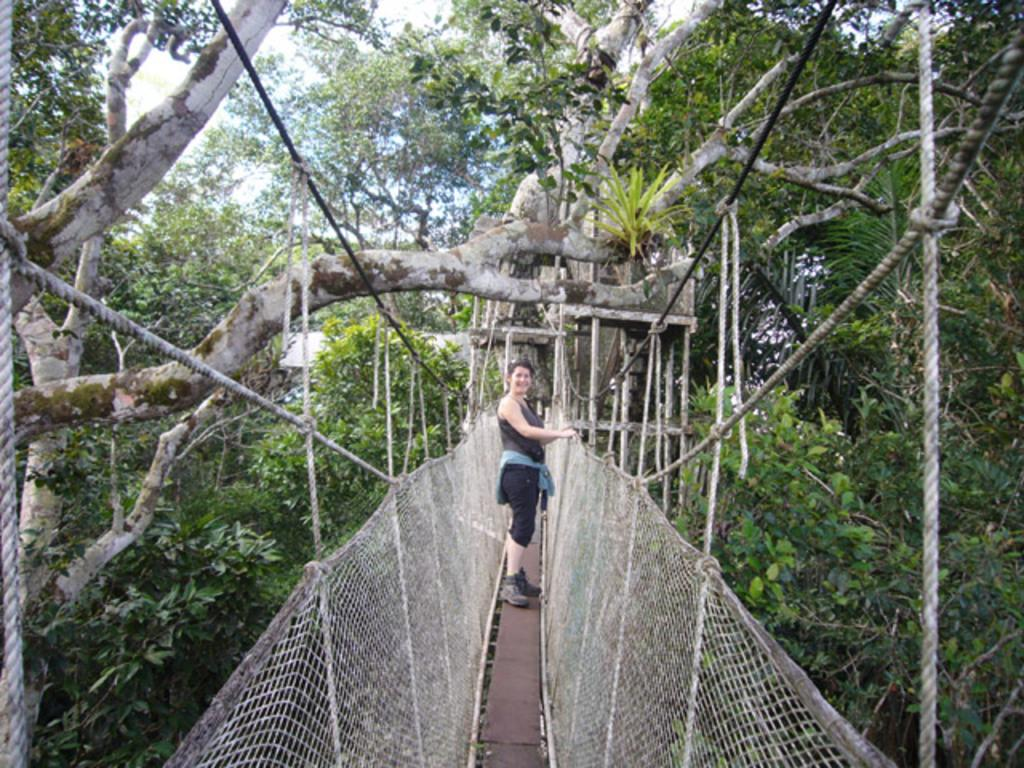Who is present in the image? There is a woman in the image. What is the woman doing in the image? The woman is standing on a rope bridge. What is the woman's facial expression in the image? The woman is smiling. What can be seen in the background of the image? There are trees around the bridge. What type of scissors can be seen cutting the rope bridge in the image? There are no scissors present in the image, and the rope bridge is not being cut. 